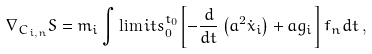<formula> <loc_0><loc_0><loc_500><loc_500>\nabla _ { { C } _ { i , n } } S = m _ { i } \int \lim i t s _ { 0 } ^ { t _ { 0 } } { \left [ { - \frac { d } { d t } \left ( { a ^ { 2 } { \dot { x } } _ { i } } \right ) + a { g } _ { i } } \right ] f _ { n } d t } \, ,</formula> 